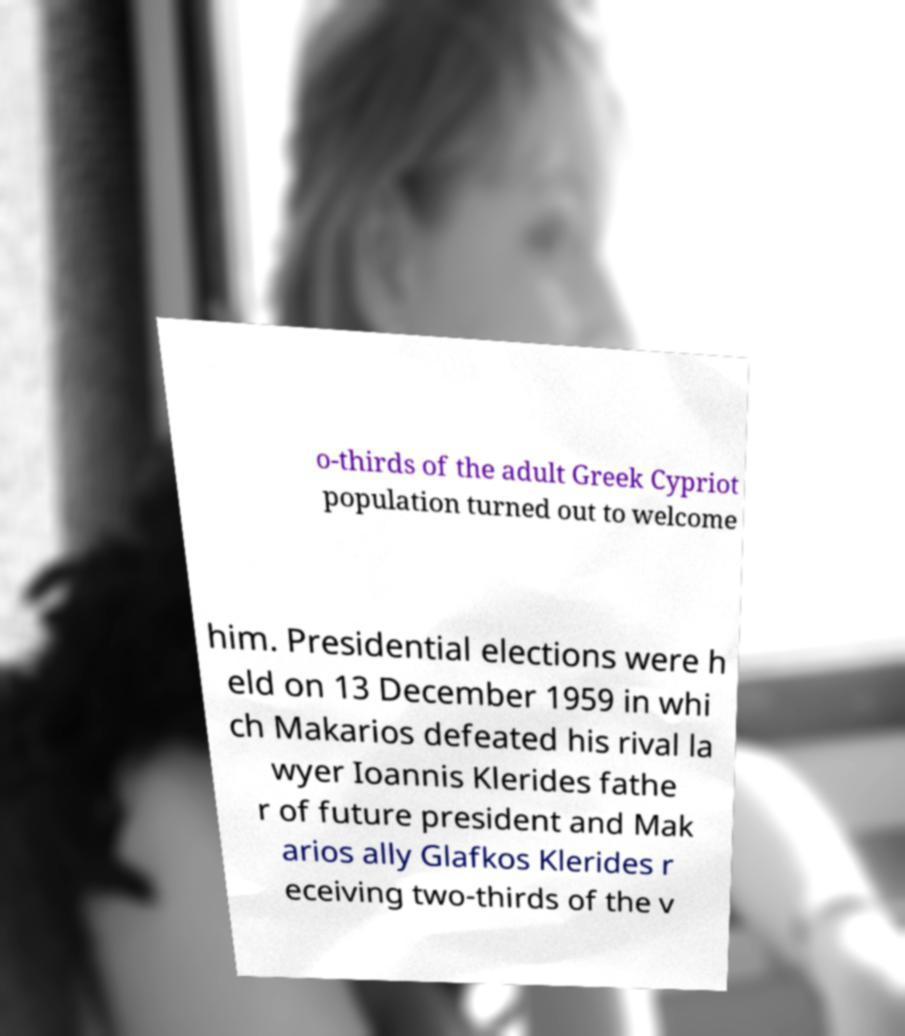Please read and relay the text visible in this image. What does it say? o-thirds of the adult Greek Cypriot population turned out to welcome him. Presidential elections were h eld on 13 December 1959 in whi ch Makarios defeated his rival la wyer Ioannis Klerides fathe r of future president and Mak arios ally Glafkos Klerides r eceiving two-thirds of the v 